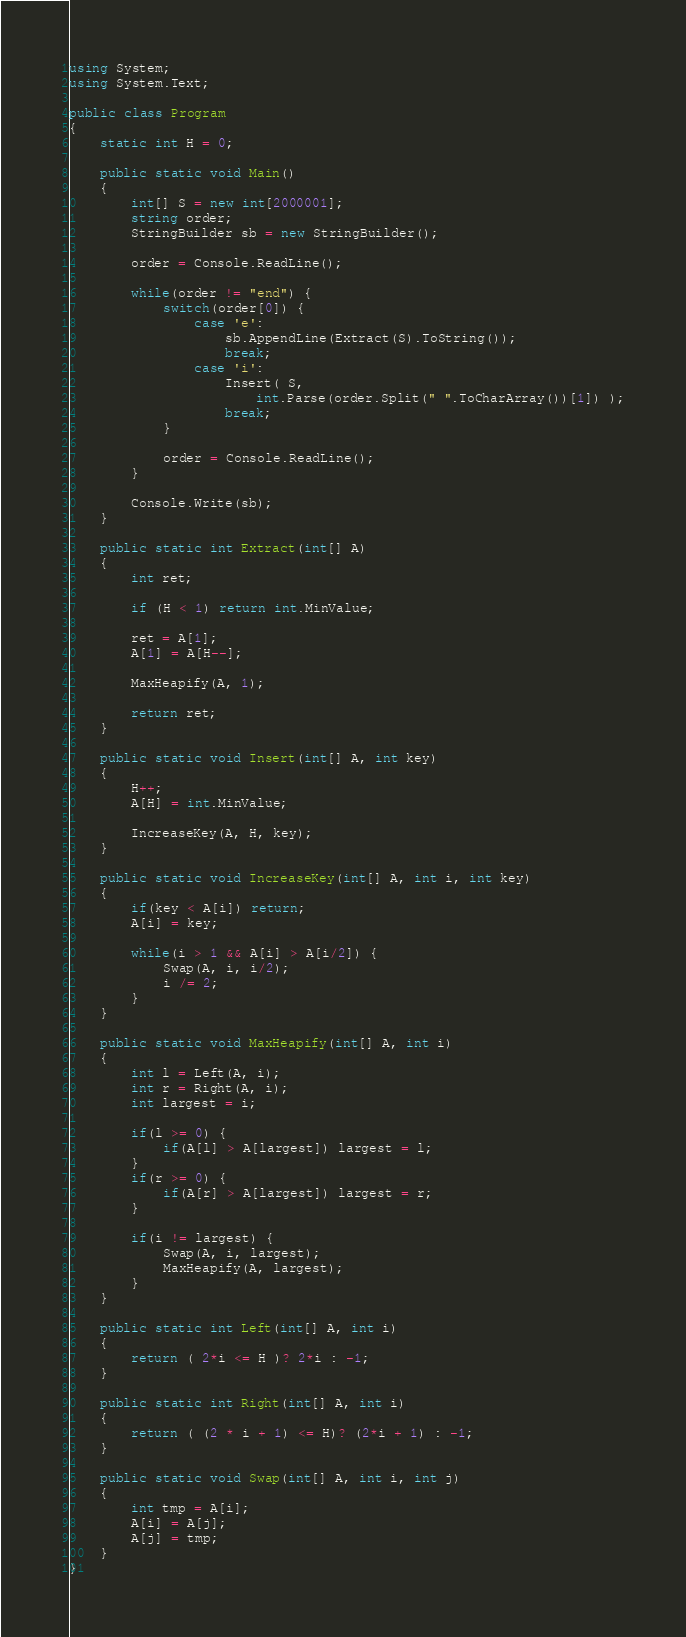Convert code to text. <code><loc_0><loc_0><loc_500><loc_500><_C#_>using System;
using System.Text;
					
public class Program
{
	static int H = 0;
	
	public static void Main()
	{
		int[] S = new int[2000001];
		string order;
		StringBuilder sb = new StringBuilder();
		
		order = Console.ReadLine();
		
		while(order != "end") {
			switch(order[0]) {
				case 'e':
					sb.AppendLine(Extract(S).ToString());
					break;
				case 'i':
					Insert( S, 
						int.Parse(order.Split(" ".ToCharArray())[1]) );
					break;
			}
			
			order = Console.ReadLine();
		}
		
		Console.Write(sb);
	}
	
	public static int Extract(int[] A)
	{
		int ret;
		
		if (H < 1) return int.MinValue;
		
		ret = A[1];
		A[1] = A[H--];
		
		MaxHeapify(A, 1);	
		
		return ret;
	}
	
	public static void Insert(int[] A, int key)
	{
		H++;
		A[H] = int.MinValue;
		
		IncreaseKey(A, H, key);
	}
	
	public static void IncreaseKey(int[] A, int i, int key)
	{
		if(key < A[i]) return;
		A[i] = key;
		
		while(i > 1 && A[i] > A[i/2]) {
			Swap(A, i, i/2);
			i /= 2;
		}
	}
	
	public static void MaxHeapify(int[] A, int i)
	{
		int l = Left(A, i);
		int r = Right(A, i);
		int largest = i;
		
		if(l >= 0) {
			if(A[l] > A[largest]) largest = l;	
		}
		if(r >= 0) {
			if(A[r] > A[largest]) largest = r;
		}
		
		if(i != largest) {
			Swap(A, i, largest);
			MaxHeapify(A, largest);
		}
	}
	
	public static int Left(int[] A, int i)
	{	
		return ( 2*i <= H )? 2*i : -1;
	}
	
	public static int Right(int[] A, int i)
	{	
		return ( (2 * i + 1) <= H)? (2*i + 1) : -1;
	}
	
	public static void Swap(int[] A, int i, int j)
	{
		int tmp = A[i];
		A[i] = A[j];
		A[j] = tmp;
	}
}</code> 